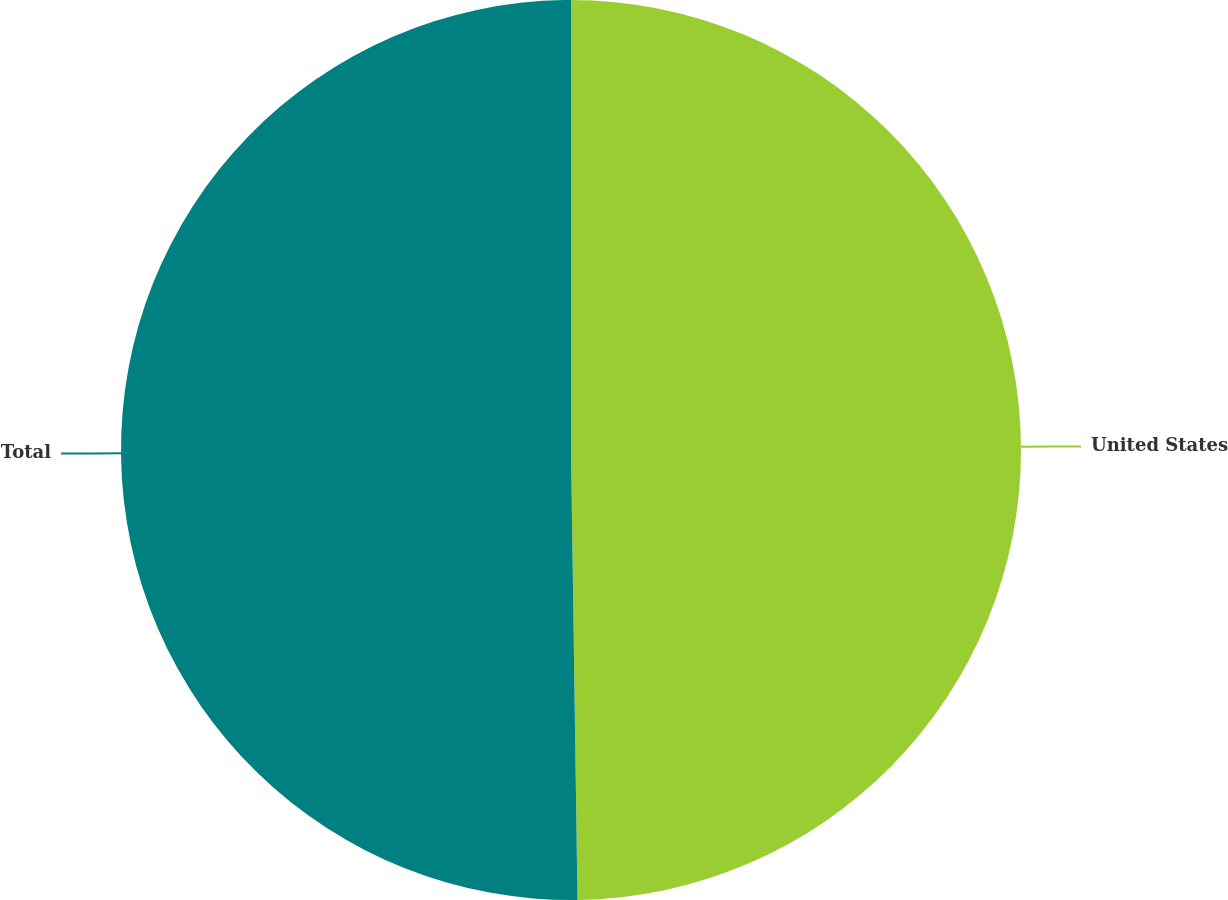<chart> <loc_0><loc_0><loc_500><loc_500><pie_chart><fcel>United States<fcel>Total<nl><fcel>49.77%<fcel>50.23%<nl></chart> 